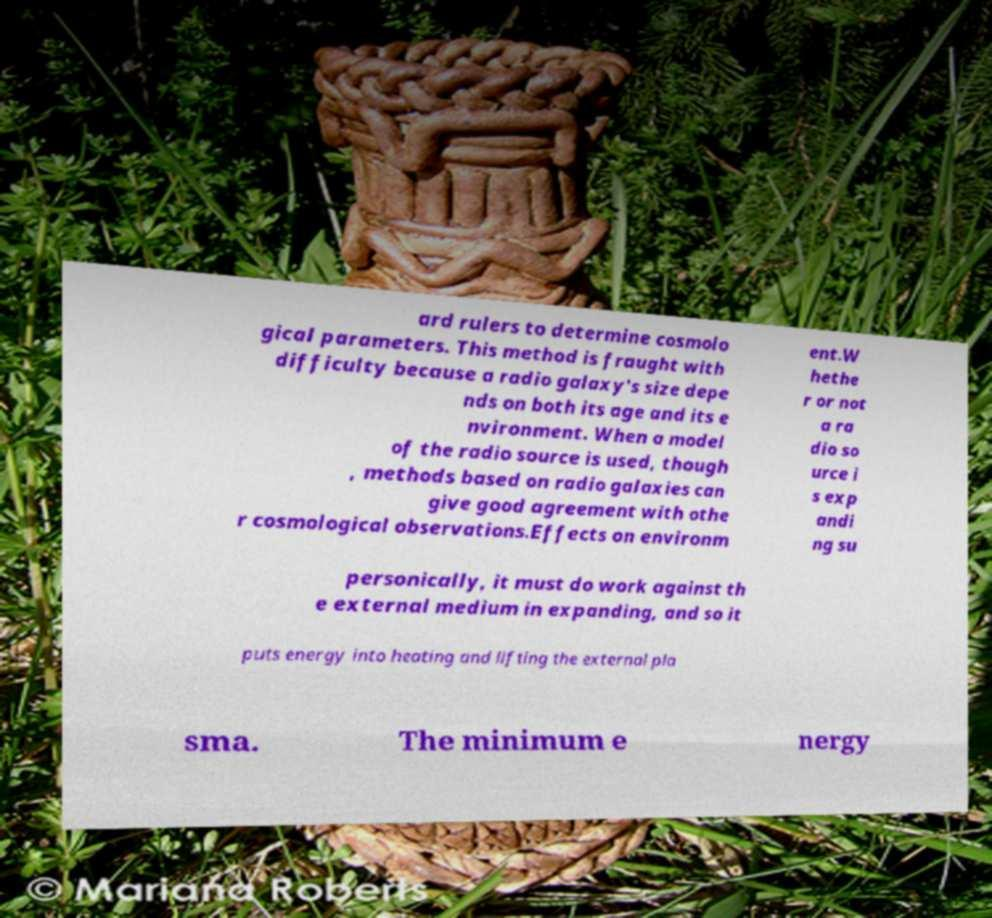Please read and relay the text visible in this image. What does it say? ard rulers to determine cosmolo gical parameters. This method is fraught with difficulty because a radio galaxy's size depe nds on both its age and its e nvironment. When a model of the radio source is used, though , methods based on radio galaxies can give good agreement with othe r cosmological observations.Effects on environm ent.W hethe r or not a ra dio so urce i s exp andi ng su personically, it must do work against th e external medium in expanding, and so it puts energy into heating and lifting the external pla sma. The minimum e nergy 